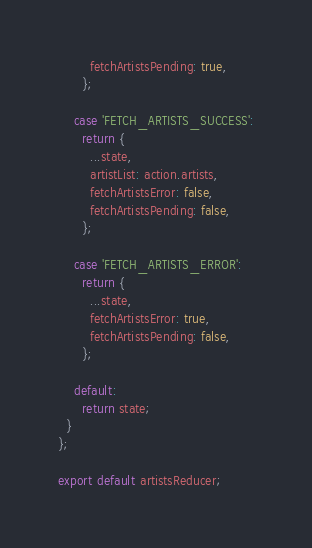<code> <loc_0><loc_0><loc_500><loc_500><_JavaScript_>        fetchArtistsPending: true,
      };

    case 'FETCH_ARTISTS_SUCCESS':
      return {
        ...state,
        artistList: action.artists,
        fetchArtistsError: false,
        fetchArtistsPending: false,
      };

    case 'FETCH_ARTISTS_ERROR':
      return {
        ...state,
        fetchArtistsError: true,
        fetchArtistsPending: false,
      };

    default:
      return state;
  }
};

export default artistsReducer;
</code> 